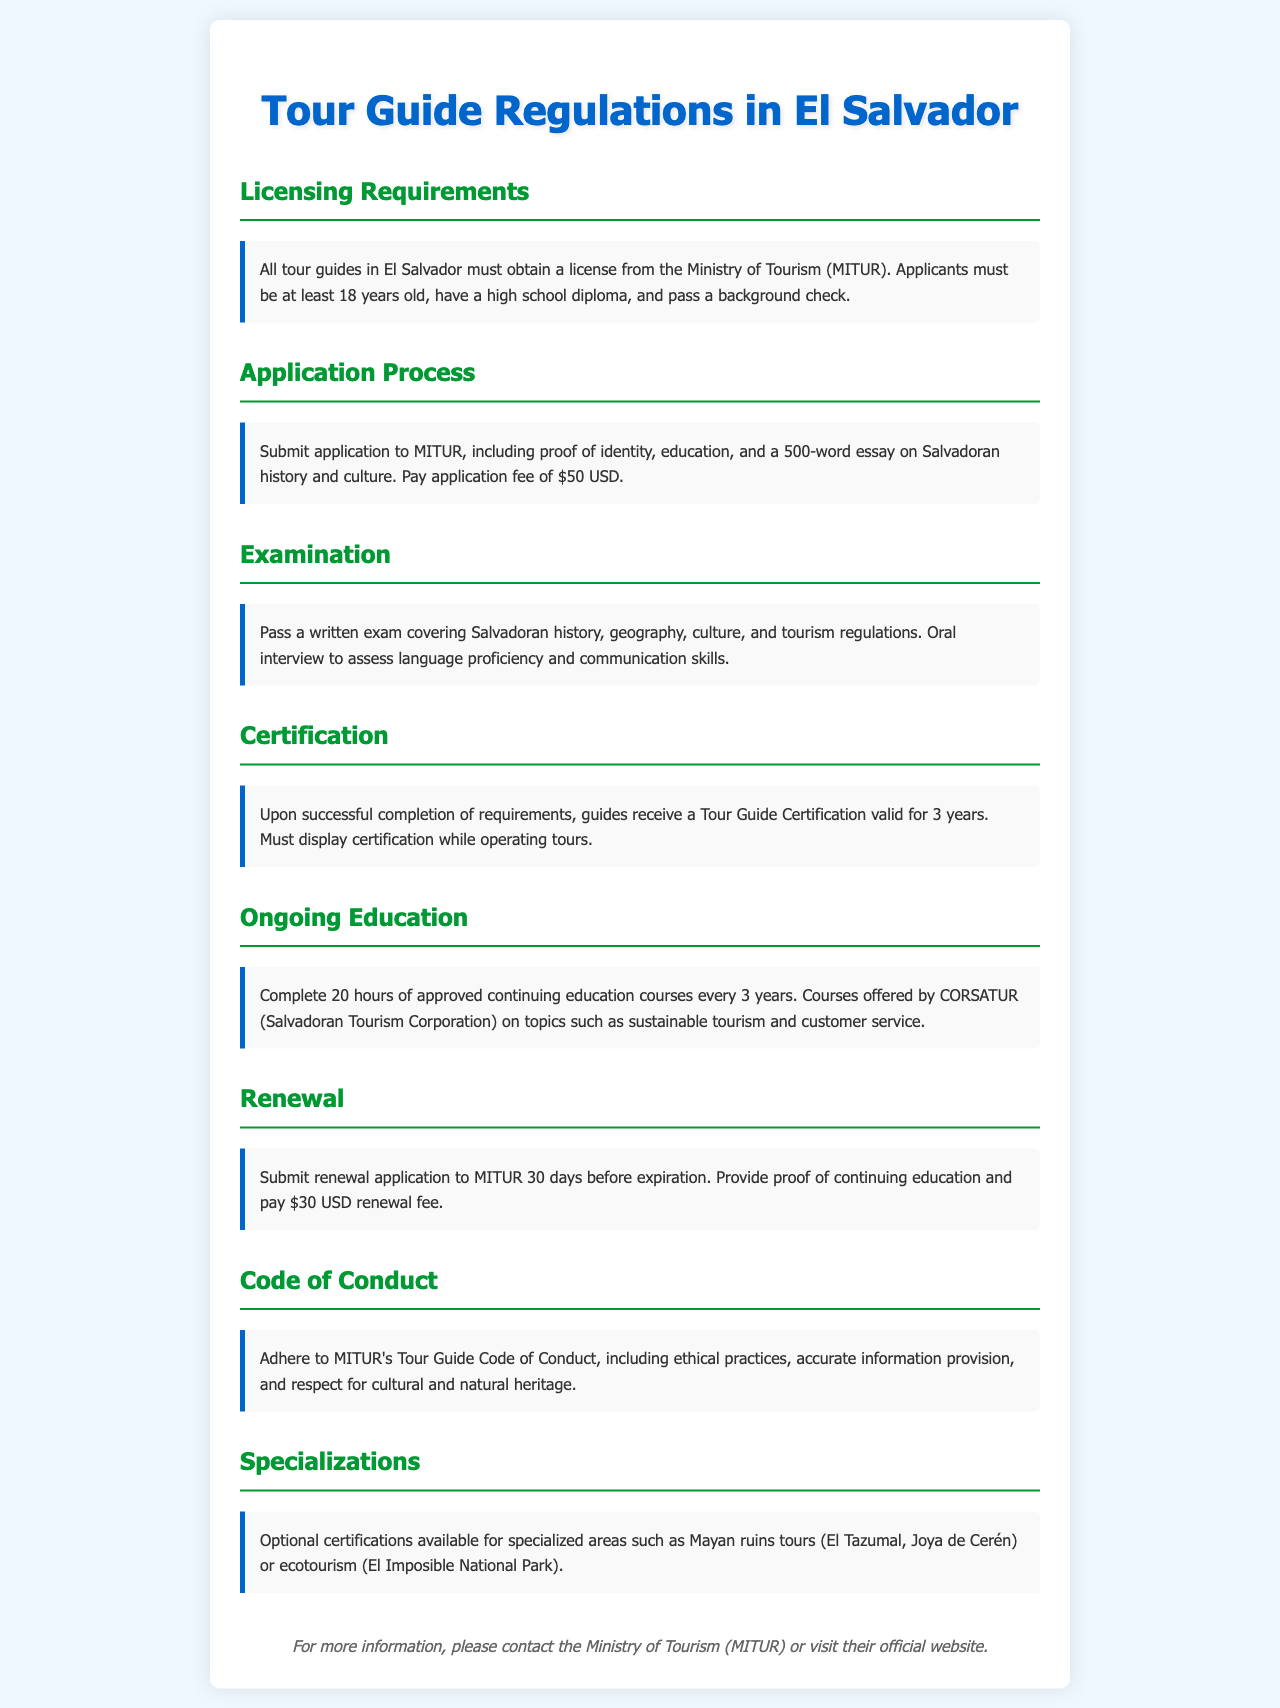What is the minimum age to become a tour guide? The document specifies that applicants must be at least 18 years old.
Answer: 18 years old What is the application fee for a tour guide license? The application fee stated in the document is $50 USD.
Answer: $50 USD How long is the Tour Guide Certification valid? The certification is valid for 3 years as per the information provided.
Answer: 3 years How many hours of continuing education are required every 3 years? The requirement for continuing education is 20 hours every 3 years.
Answer: 20 hours What is required for the license renewal application? The renewal application must provide proof of continuing education and pay a renewal fee.
Answer: Proof of continuing education and $30 USD What type of exam must applicants pass? Applicants must pass a written exam covering Salvadoran history, geography, culture, and tourism regulations.
Answer: Written exam What does the Code of Conduct emphasize? The Code of Conduct emphasizes ethical practices, accurate information, and respect for cultural heritage.
Answer: Ethical practices, accurate information, and respect for cultural heritage Is there an optional certification available for any specific tour area? Yes, optional certifications are available for specialized areas such as Mayan ruins tours or ecotourism.
Answer: Yes, for Mayan ruins and ecotourism 